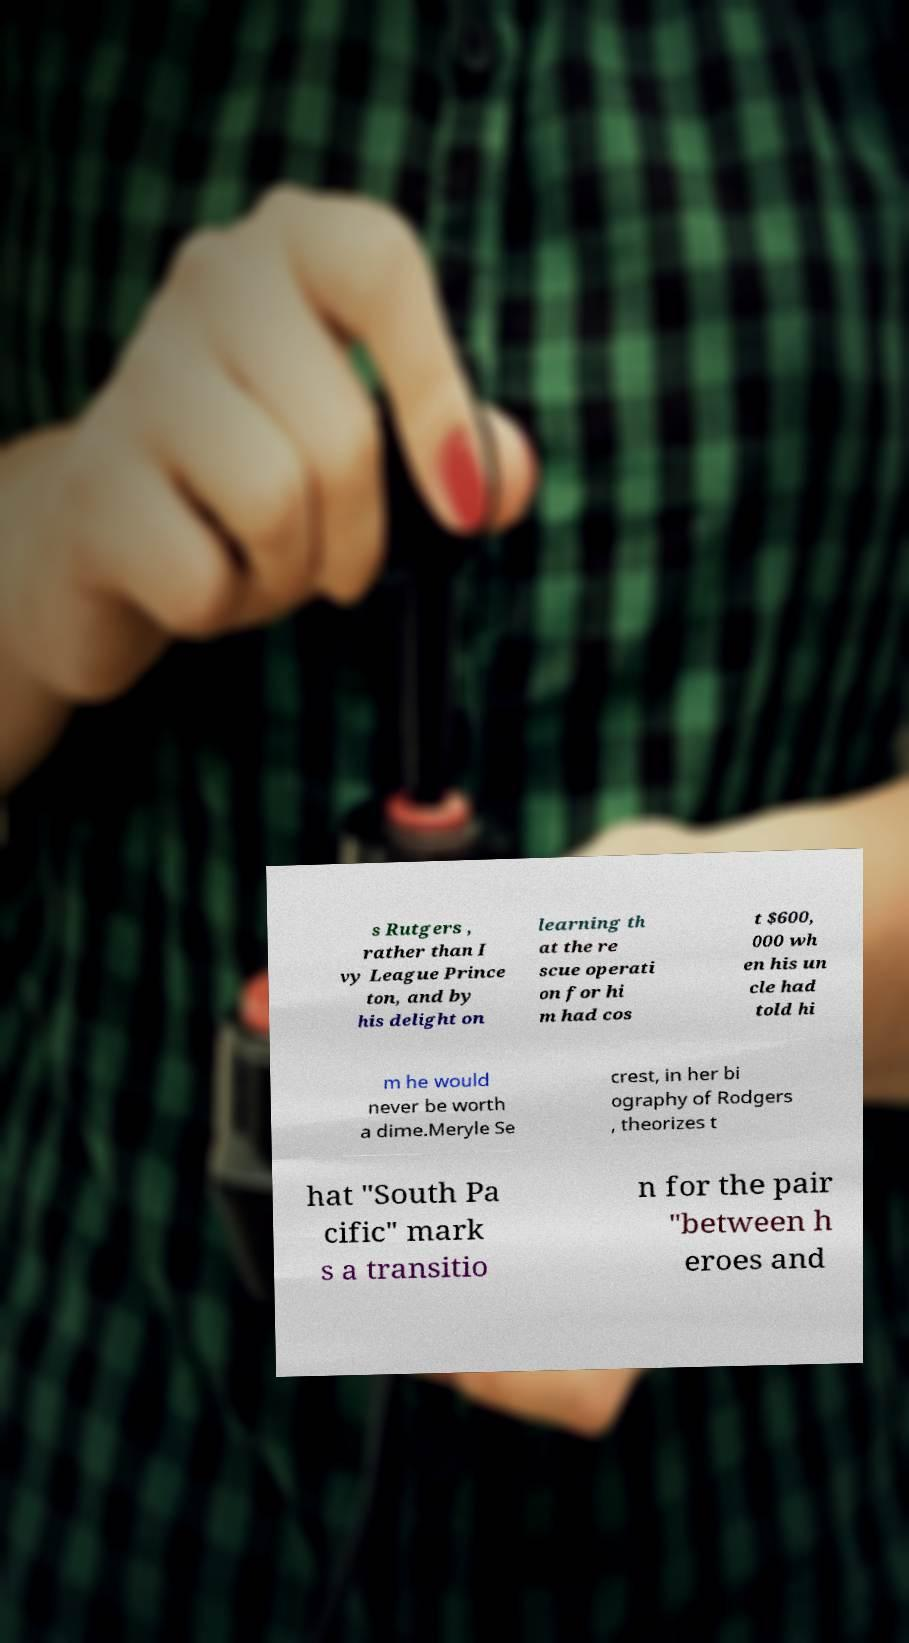I need the written content from this picture converted into text. Can you do that? s Rutgers , rather than I vy League Prince ton, and by his delight on learning th at the re scue operati on for hi m had cos t $600, 000 wh en his un cle had told hi m he would never be worth a dime.Meryle Se crest, in her bi ography of Rodgers , theorizes t hat "South Pa cific" mark s a transitio n for the pair "between h eroes and 